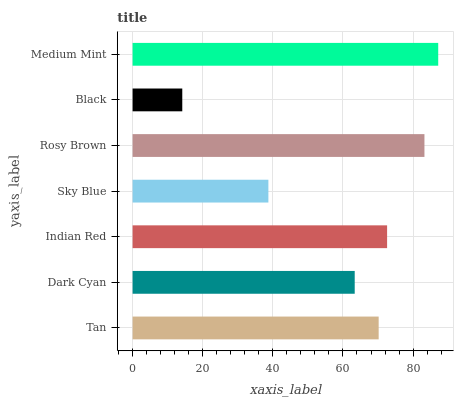Is Black the minimum?
Answer yes or no. Yes. Is Medium Mint the maximum?
Answer yes or no. Yes. Is Dark Cyan the minimum?
Answer yes or no. No. Is Dark Cyan the maximum?
Answer yes or no. No. Is Tan greater than Dark Cyan?
Answer yes or no. Yes. Is Dark Cyan less than Tan?
Answer yes or no. Yes. Is Dark Cyan greater than Tan?
Answer yes or no. No. Is Tan less than Dark Cyan?
Answer yes or no. No. Is Tan the high median?
Answer yes or no. Yes. Is Tan the low median?
Answer yes or no. Yes. Is Black the high median?
Answer yes or no. No. Is Rosy Brown the low median?
Answer yes or no. No. 